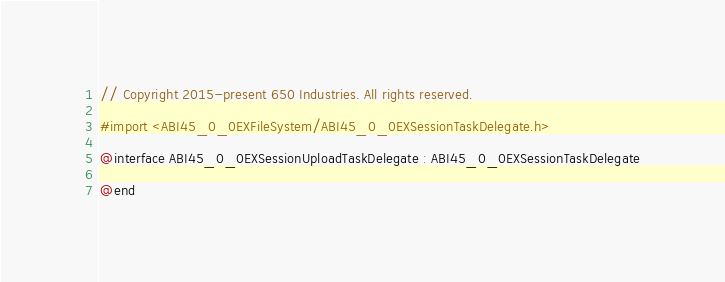Convert code to text. <code><loc_0><loc_0><loc_500><loc_500><_C_>// Copyright 2015-present 650 Industries. All rights reserved.

#import <ABI45_0_0EXFileSystem/ABI45_0_0EXSessionTaskDelegate.h>

@interface ABI45_0_0EXSessionUploadTaskDelegate : ABI45_0_0EXSessionTaskDelegate

@end

</code> 